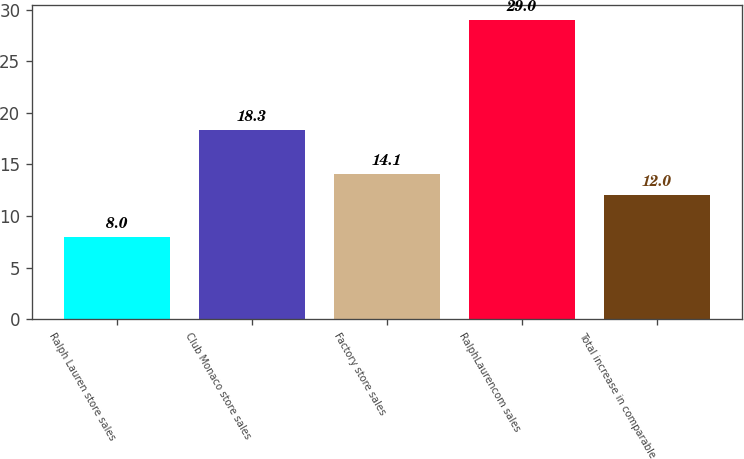Convert chart to OTSL. <chart><loc_0><loc_0><loc_500><loc_500><bar_chart><fcel>Ralph Lauren store sales<fcel>Club Monaco store sales<fcel>Factory store sales<fcel>RalphLaurencom sales<fcel>Total increase in comparable<nl><fcel>8<fcel>18.3<fcel>14.1<fcel>29<fcel>12<nl></chart> 